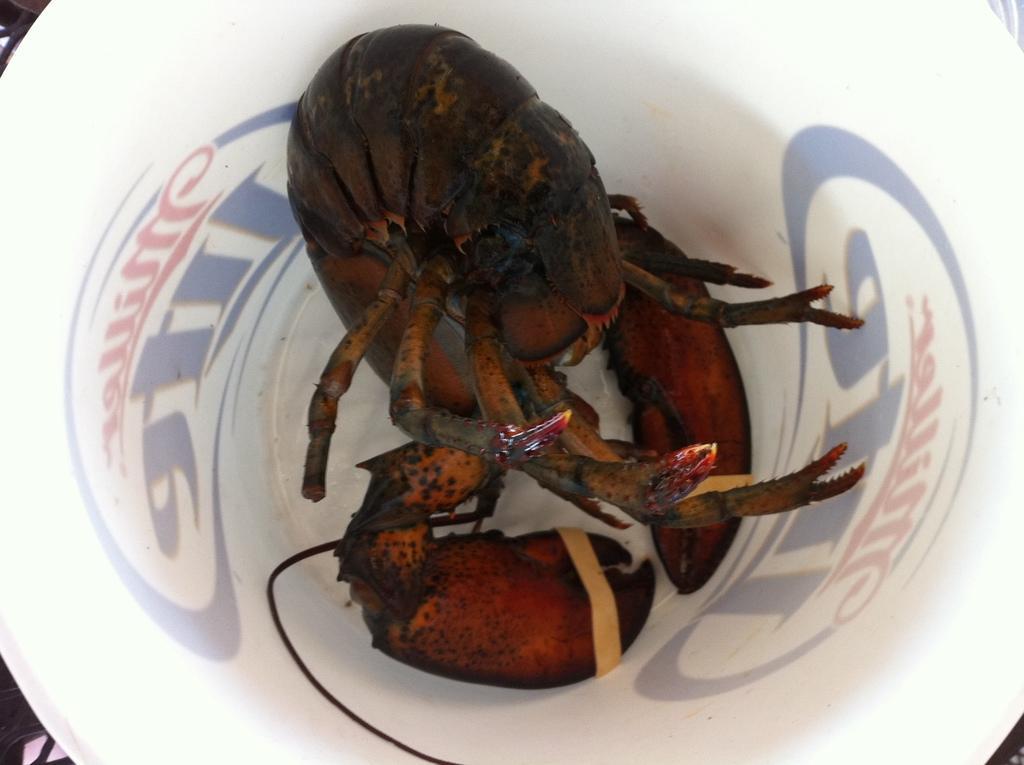Describe this image in one or two sentences. In this image we can see some crabs in a bowl, also we can see some texts around the bowl. 